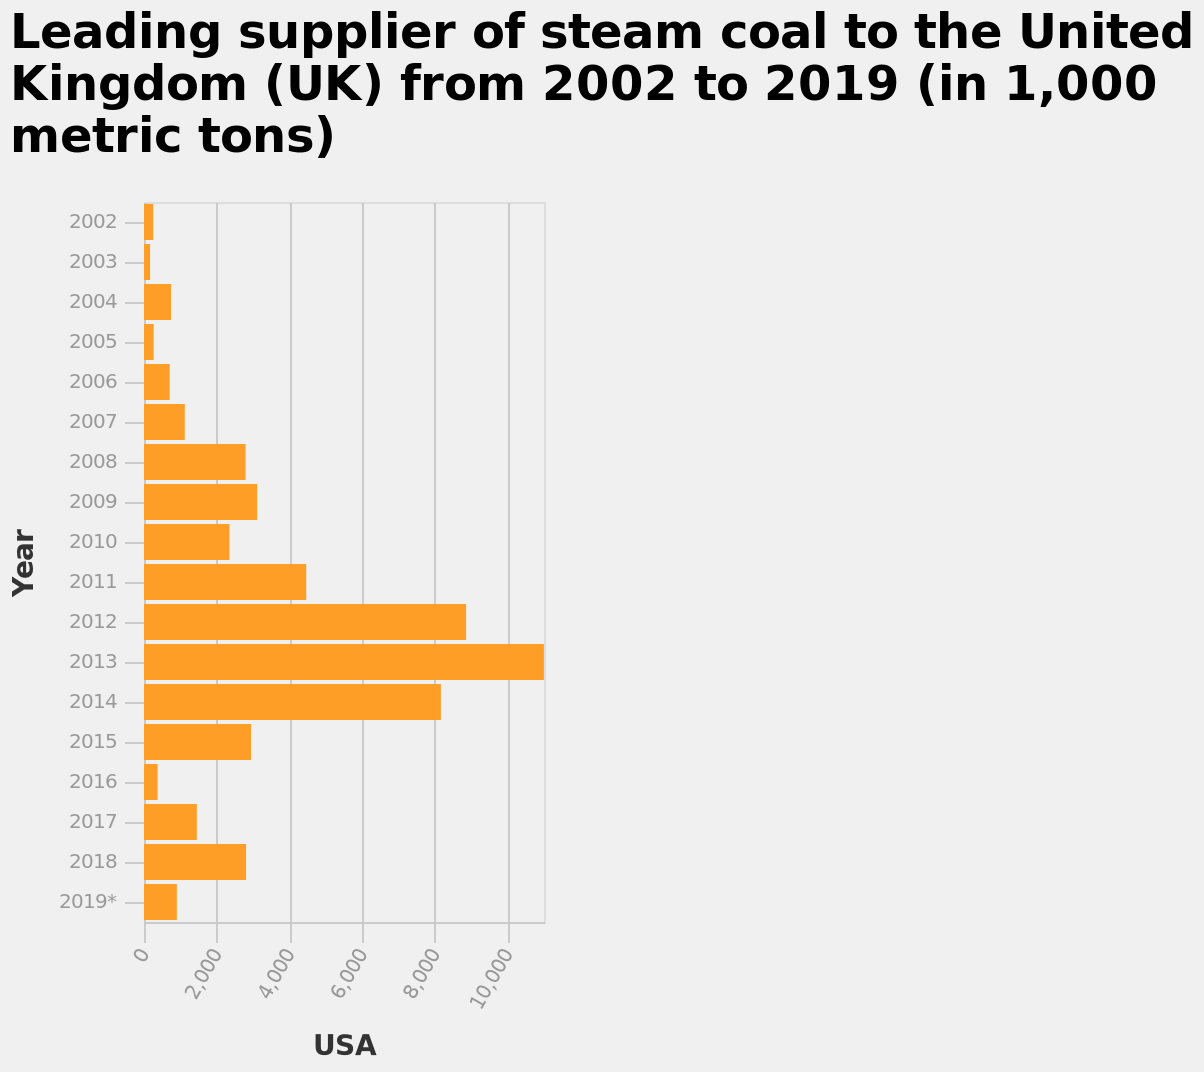<image>
What trend does the chart show for steam coal supply from the USA between 2002 and 2013? The chart displays a general increase in steam coal supply from the USA from 2002 to 2013. What is the time period covered in the bar plot? The time period covered in the bar plot is from 2002 to 2019. Did the steam coal supply from the USA continuously increase throughout the entire period? No, the steam coal supply from the USA increased from 2002 to 2013 and then started to decrease. Does the chart display a general decrease in steam coal supply from the USA from 2002 to 2013? No.The chart displays a general increase in steam coal supply from the USA from 2002 to 2013. 